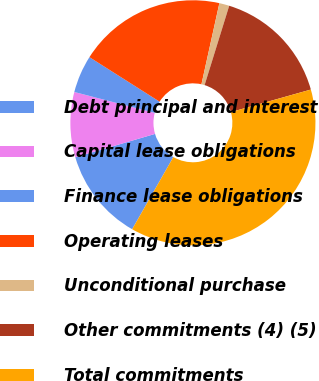<chart> <loc_0><loc_0><loc_500><loc_500><pie_chart><fcel>Debt principal and interest<fcel>Capital lease obligations<fcel>Finance lease obligations<fcel>Operating leases<fcel>Unconditional purchase<fcel>Other commitments (4) (5)<fcel>Total commitments<nl><fcel>12.21%<fcel>8.58%<fcel>4.95%<fcel>19.47%<fcel>1.32%<fcel>15.84%<fcel>37.63%<nl></chart> 